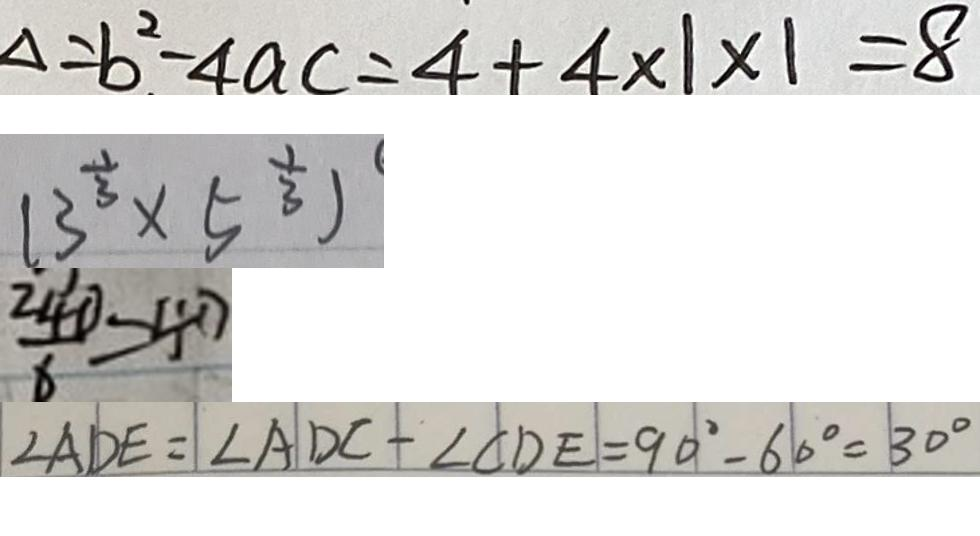Convert formula to latex. <formula><loc_0><loc_0><loc_500><loc_500>\Delta = b ^ { 2 } - 4 a c = 4 + 4 \times 1 \times 1 = 8 
 ( 3 ^ { \frac { 1 } { 3 } } \times 5 ^ { \frac { 1 } { 3 } } ) 
 \frac { 2 4 0 } { 6 } = 4 0 
 \angle A D E = \angle A D C - \angle C D E = 9 0 ^ { \circ } - 6 0 ^ { \circ } = 3 0 ^ { \circ }</formula> 